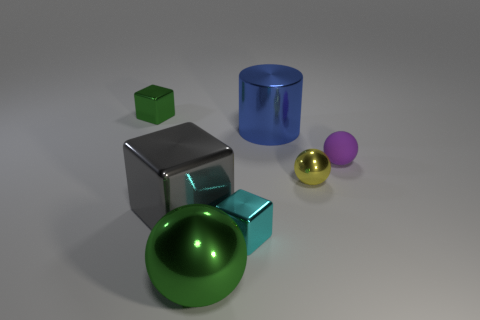Add 1 yellow metallic things. How many objects exist? 8 Subtract all spheres. How many objects are left? 4 Subtract all big red things. Subtract all gray things. How many objects are left? 6 Add 7 big balls. How many big balls are left? 8 Add 5 small purple rubber spheres. How many small purple rubber spheres exist? 6 Subtract 0 brown cubes. How many objects are left? 7 